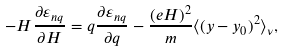Convert formula to latex. <formula><loc_0><loc_0><loc_500><loc_500>- H \frac { \partial \varepsilon _ { n q } } { \partial H } = q \frac { \partial \varepsilon _ { n q } } { \partial q } - \frac { ( e H ) ^ { 2 } } { m } \langle ( y - y _ { 0 } ) ^ { 2 } \rangle _ { \nu } ,</formula> 